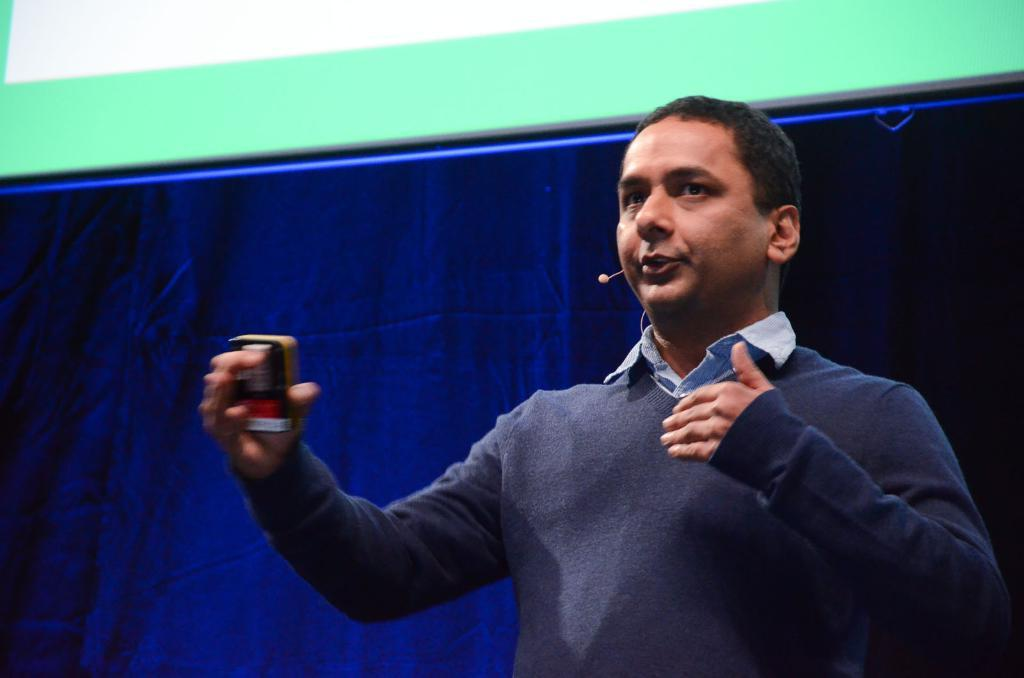What is the man in the image doing? The man is standing and talking in the image. What is the man holding in the image? The man is holding an object in the image. What can be seen in the background of the image? There is a curtain and a wall in the background of the image. What type of crime is being committed in the image? There is no crime being committed in the image; it simply shows a man standing and talking while holding an object. How many buttons can be seen on the man's clothing in the image? There is no information about the man's clothing or buttons in the image. 